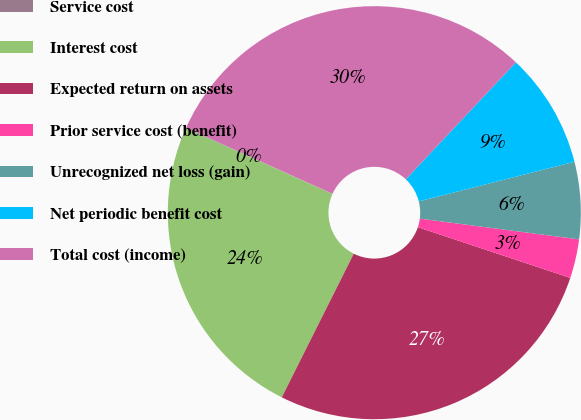Convert chart. <chart><loc_0><loc_0><loc_500><loc_500><pie_chart><fcel>Service cost<fcel>Interest cost<fcel>Expected return on assets<fcel>Prior service cost (benefit)<fcel>Unrecognized net loss (gain)<fcel>Net periodic benefit cost<fcel>Total cost (income)<nl><fcel>0.06%<fcel>24.3%<fcel>27.28%<fcel>3.05%<fcel>6.03%<fcel>9.01%<fcel>30.27%<nl></chart> 